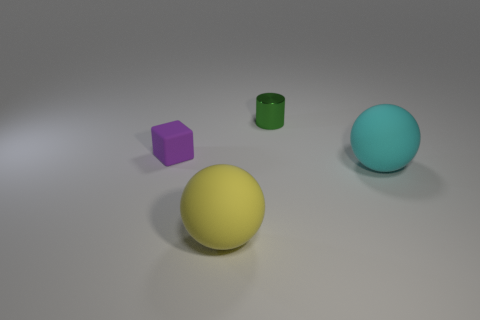Is there anything else that has the same material as the green thing?
Ensure brevity in your answer.  No. There is a sphere in front of the big rubber sphere behind the yellow matte sphere; what size is it?
Provide a succinct answer. Large. Do the tiny thing that is behind the small purple object and the rubber object that is behind the cyan matte ball have the same shape?
Your response must be concise. No. Are there an equal number of things that are in front of the tiny purple matte cube and large yellow objects?
Your answer should be compact. No. What is the color of the other large thing that is the same shape as the cyan object?
Your answer should be compact. Yellow. Is the large sphere left of the cyan rubber object made of the same material as the cyan object?
Keep it short and to the point. Yes. What number of big objects are red shiny blocks or matte balls?
Your response must be concise. 2. The yellow thing is what size?
Your answer should be very brief. Large. Does the green metal cylinder have the same size as the sphere that is behind the big yellow object?
Give a very brief answer. No. How many red objects are matte things or small metal cylinders?
Ensure brevity in your answer.  0. 